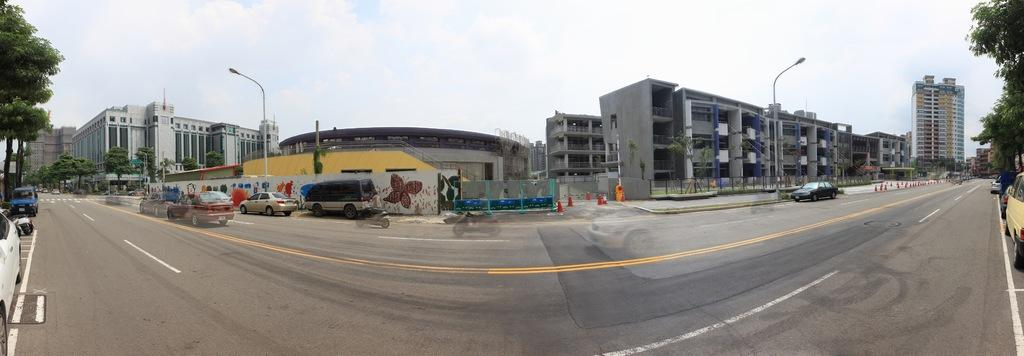What is happening on the road in the image? There are vehicles on the road in the image. What objects are placed on the road in the image? There are traffic cones on the road in the image. What can be seen in the background of the image? There are buildings, trees, streetlights, and the sky visible in the background of the image. What is the purpose of the root in the image? There is no root present in the image. How does the stomach affect the vehicles in the image? There is no stomach present in the image, and therefore it cannot affect the vehicles. 